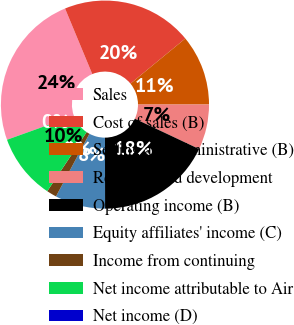<chart> <loc_0><loc_0><loc_500><loc_500><pie_chart><fcel>Sales<fcel>Cost of sales (B)<fcel>Selling and administrative (B)<fcel>Research and development<fcel>Operating income (B)<fcel>Equity affiliates' income (C)<fcel>Income from continuing<fcel>Net income attributable to Air<fcel>Net income (D)<nl><fcel>24.22%<fcel>20.31%<fcel>10.94%<fcel>7.03%<fcel>17.97%<fcel>7.81%<fcel>1.56%<fcel>10.16%<fcel>0.0%<nl></chart> 